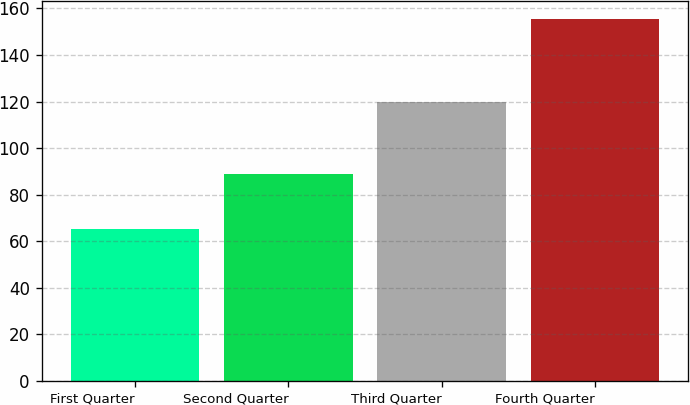Convert chart. <chart><loc_0><loc_0><loc_500><loc_500><bar_chart><fcel>First Quarter<fcel>Second Quarter<fcel>Third Quarter<fcel>Fourth Quarter<nl><fcel>65.25<fcel>88.7<fcel>119.97<fcel>155.49<nl></chart> 